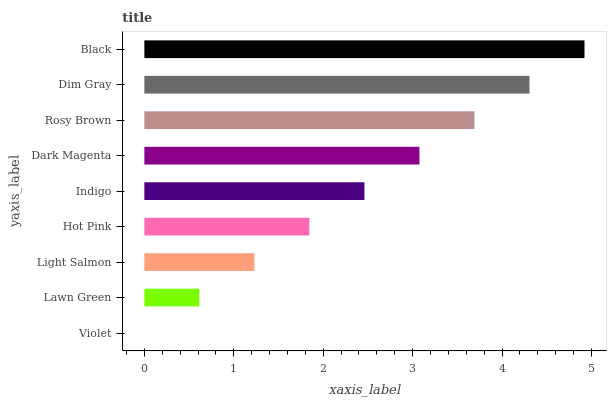Is Violet the minimum?
Answer yes or no. Yes. Is Black the maximum?
Answer yes or no. Yes. Is Lawn Green the minimum?
Answer yes or no. No. Is Lawn Green the maximum?
Answer yes or no. No. Is Lawn Green greater than Violet?
Answer yes or no. Yes. Is Violet less than Lawn Green?
Answer yes or no. Yes. Is Violet greater than Lawn Green?
Answer yes or no. No. Is Lawn Green less than Violet?
Answer yes or no. No. Is Indigo the high median?
Answer yes or no. Yes. Is Indigo the low median?
Answer yes or no. Yes. Is Dim Gray the high median?
Answer yes or no. No. Is Light Salmon the low median?
Answer yes or no. No. 